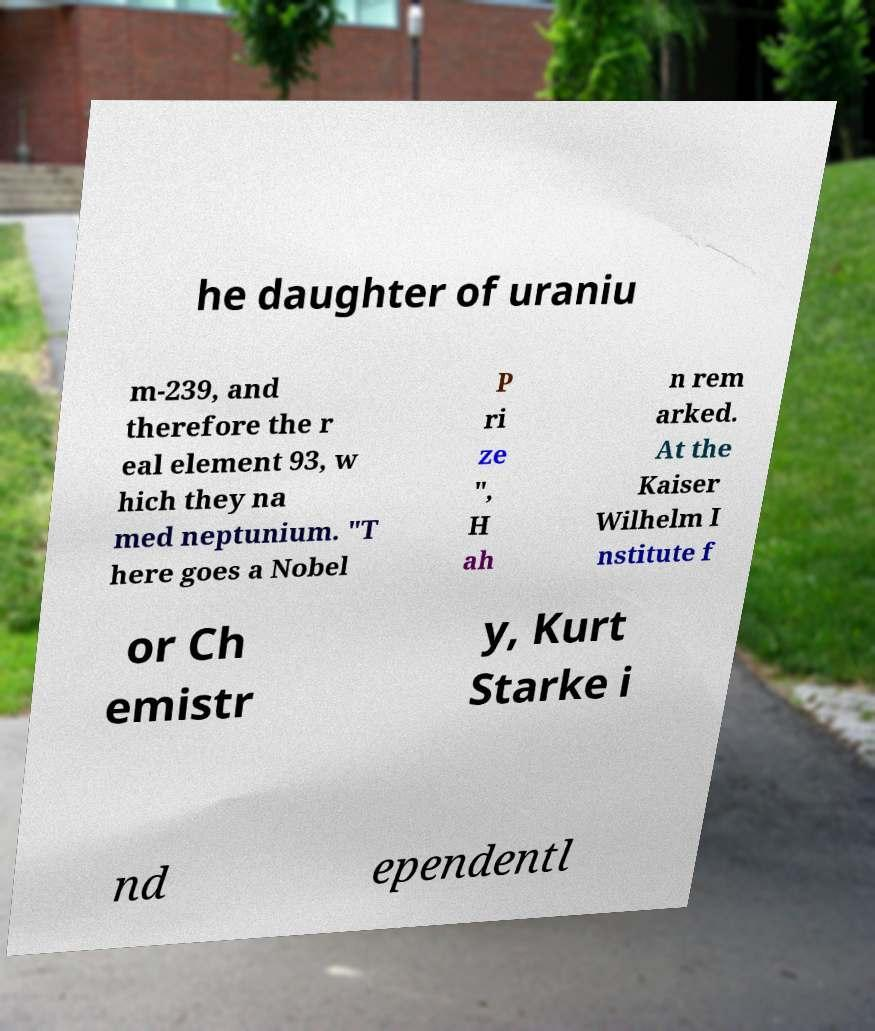I need the written content from this picture converted into text. Can you do that? he daughter of uraniu m-239, and therefore the r eal element 93, w hich they na med neptunium. "T here goes a Nobel P ri ze ", H ah n rem arked. At the Kaiser Wilhelm I nstitute f or Ch emistr y, Kurt Starke i nd ependentl 